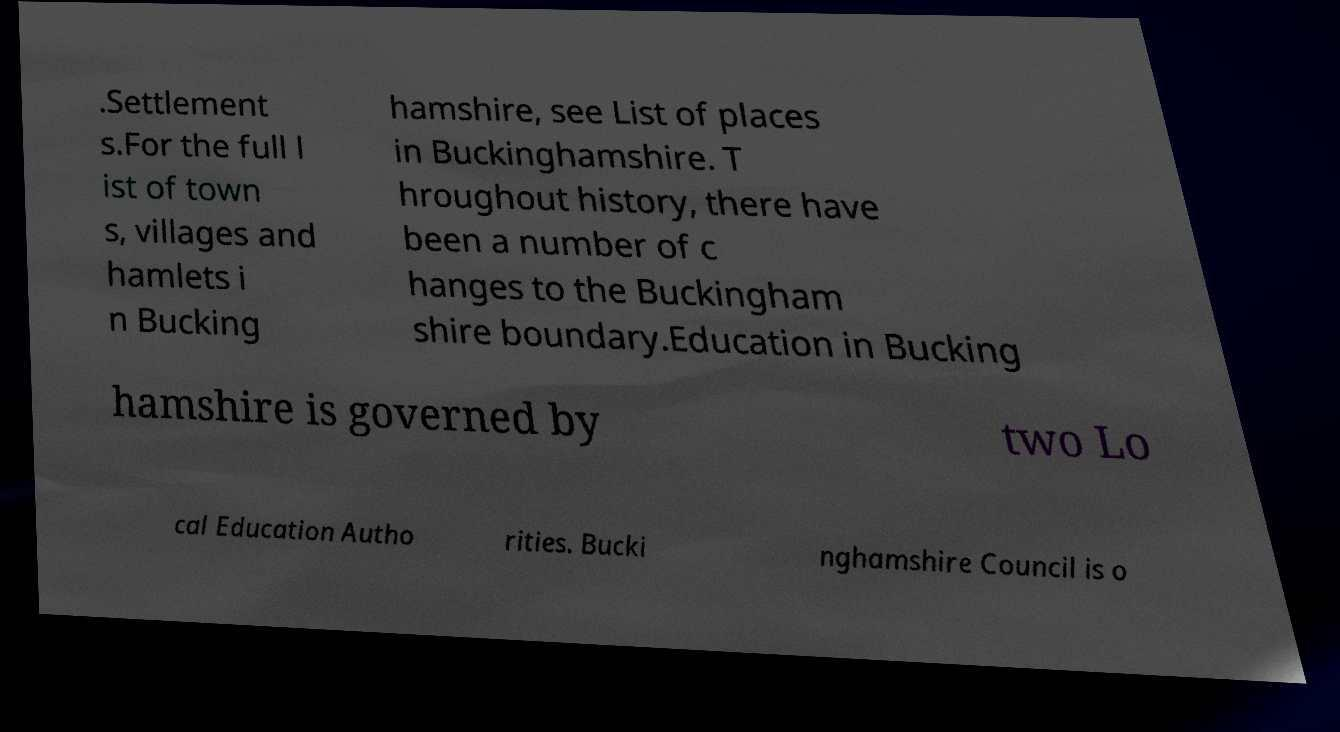I need the written content from this picture converted into text. Can you do that? .Settlement s.For the full l ist of town s, villages and hamlets i n Bucking hamshire, see List of places in Buckinghamshire. T hroughout history, there have been a number of c hanges to the Buckingham shire boundary.Education in Bucking hamshire is governed by two Lo cal Education Autho rities. Bucki nghamshire Council is o 